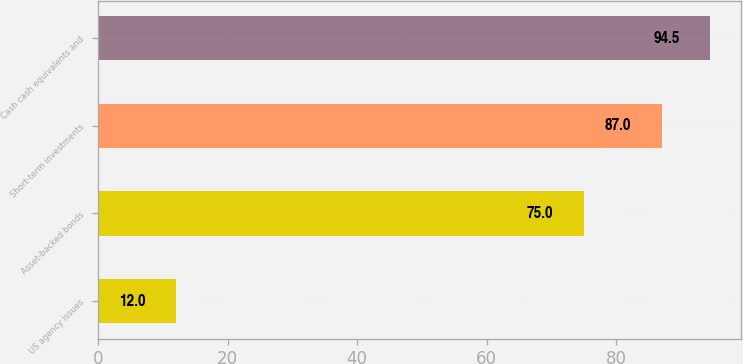Convert chart to OTSL. <chart><loc_0><loc_0><loc_500><loc_500><bar_chart><fcel>US agency issues<fcel>Asset-backed bonds<fcel>Short-term investments<fcel>Cash cash equivalents and<nl><fcel>12<fcel>75<fcel>87<fcel>94.5<nl></chart> 